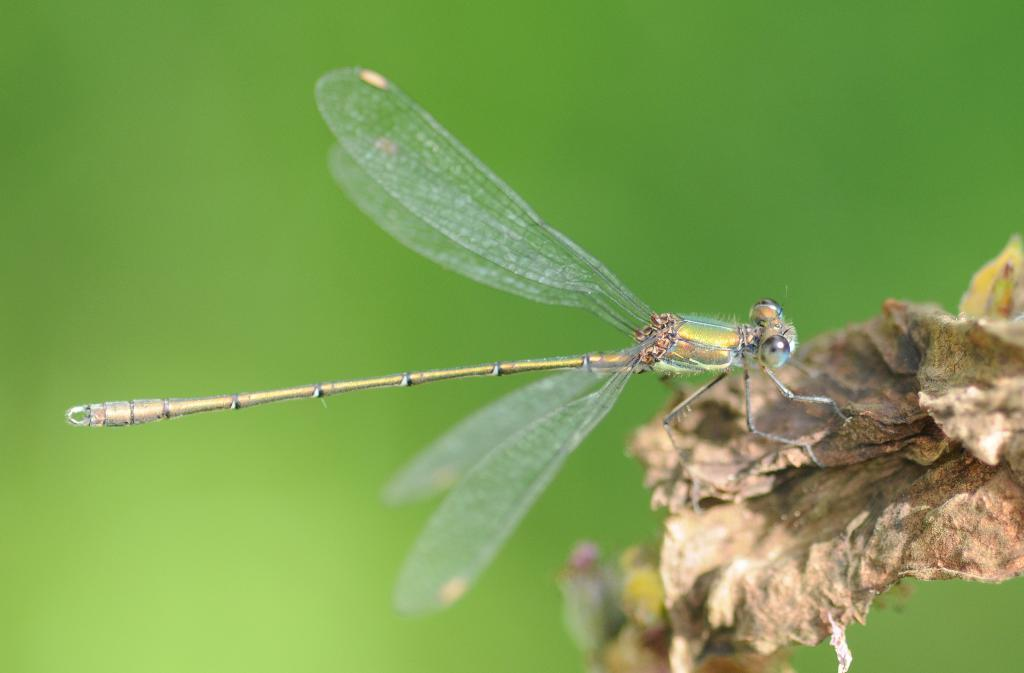What insect is present in the image? There is a dragonfly in the image. What is the dragonfly standing on? The dragonfly is standing on a dry leaf. Can you describe the background of the image? The background of the image is blurry. What type of camera can be seen in the image? There is no camera present in the image; it features a dragonfly standing on a dry leaf with a blurry background. 